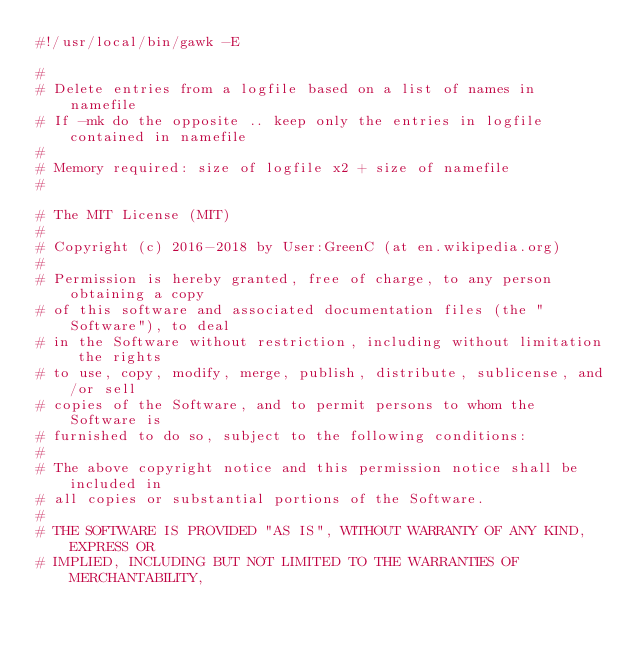Convert code to text. <code><loc_0><loc_0><loc_500><loc_500><_Awk_>#!/usr/local/bin/gawk -E

#
# Delete entries from a logfile based on a list of names in namefile
# If -mk do the opposite .. keep only the entries in logfile contained in namefile
#
# Memory required: size of logfile x2 + size of namefile
#

# The MIT License (MIT)
#
# Copyright (c) 2016-2018 by User:GreenC (at en.wikipedia.org)
#
# Permission is hereby granted, free of charge, to any person obtaining a copy
# of this software and associated documentation files (the "Software"), to deal
# in the Software without restriction, including without limitation the rights
# to use, copy, modify, merge, publish, distribute, sublicense, and/or sell
# copies of the Software, and to permit persons to whom the Software is
# furnished to do so, subject to the following conditions:
#
# The above copyright notice and this permission notice shall be included in
# all copies or substantial portions of the Software.
#
# THE SOFTWARE IS PROVIDED "AS IS", WITHOUT WARRANTY OF ANY KIND, EXPRESS OR
# IMPLIED, INCLUDING BUT NOT LIMITED TO THE WARRANTIES OF MERCHANTABILITY,</code> 